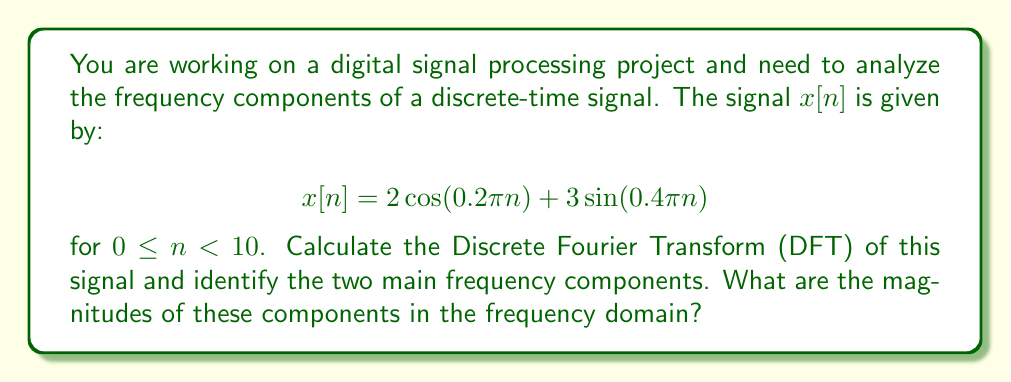Help me with this question. Let's approach this step-by-step:

1) The Discrete Fourier Transform (DFT) of a signal $x[n]$ of length N is given by:

   $$X[k] = \sum_{n=0}^{N-1} x[n] e^{-j2\pi kn/N}$$

   where $k = 0, 1, ..., N-1$

2) In this case, $N = 10$ and we have:

   $$x[n] = 2\cos(0.2\pi n) + 3\sin(0.4\pi n)$$

3) We can use Euler's formula to express the cosine and sine in complex exponential form:

   $$\cos(\theta) = \frac{e^{j\theta} + e^{-j\theta}}{2}$$
   $$\sin(\theta) = \frac{e^{j\theta} - e^{-j\theta}}{2j}$$

4) Substituting these in:

   $$x[n] = 2\left(\frac{e^{j0.2\pi n} + e^{-j0.2\pi n}}{2}\right) + 3\left(\frac{e^{j0.4\pi n} - e^{-j0.4\pi n}}{2j}\right)$$

5) Simplifying:

   $$x[n] = e^{j0.2\pi n} + e^{-j0.2\pi n} + \frac{3}{2j}(e^{j0.4\pi n} - e^{-j0.4\pi n})$$

6) Now, we need to calculate $X[k]$ for $k = 0, 1, ..., 9$. The main frequency components will appear as peaks in the magnitude spectrum $|X[k]|$.

7) Due to the properties of the DFT, we expect to see peaks at $k = 1$ and $k = 2$ (corresponding to frequencies $0.2\pi$ and $0.4\pi$ respectively), and their symmetric counterparts at $k = 9$ and $k = 8$.

8) The magnitudes of these peaks can be approximated (for large N) as:

   For the cosine component: $|X[1]| \approx |X[9]| \approx N \cdot 2/2 = N = 10$

   For the sine component: $|X[2]| \approx |X[8]| \approx N \cdot 3/2 = 15$

9) These approximations are quite accurate for this case, even though N is not very large.
Answer: The two main frequency components are at $k = 1$ (and $k = 9$) with magnitude approximately 10, and at $k = 2$ (and $k = 8$) with magnitude approximately 15. 